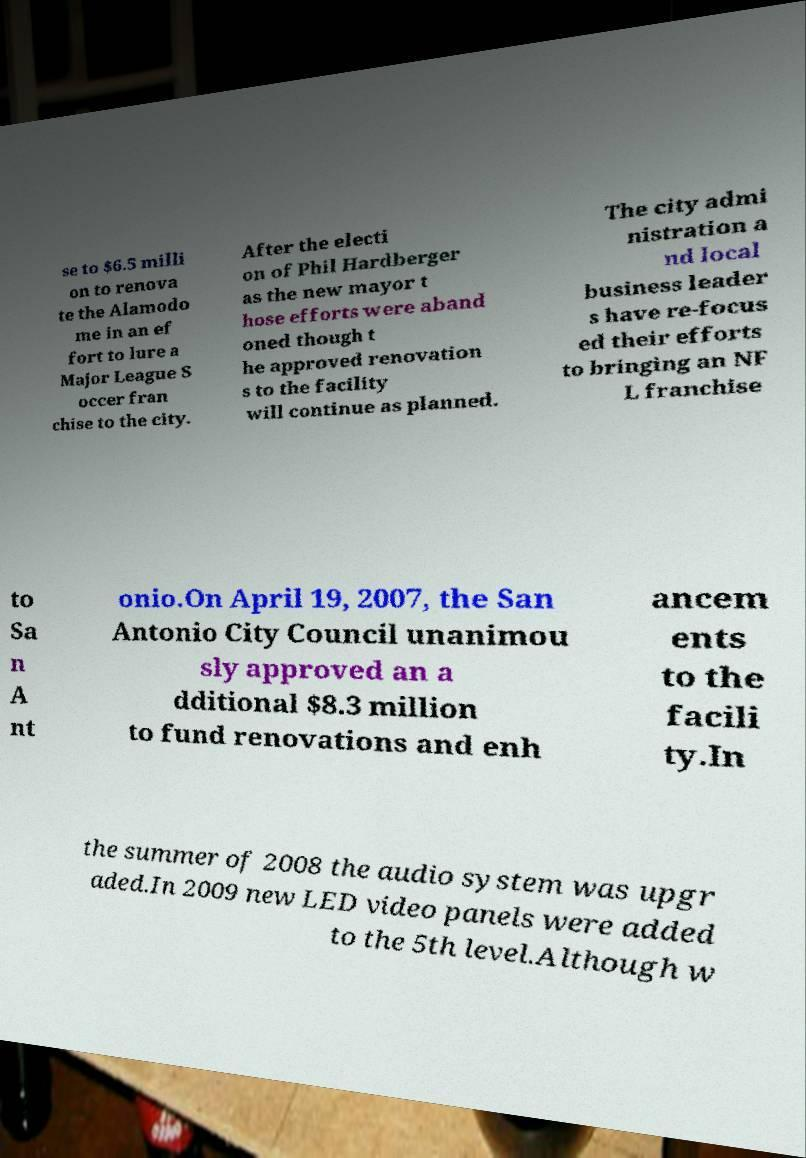Please read and relay the text visible in this image. What does it say? se to $6.5 milli on to renova te the Alamodo me in an ef fort to lure a Major League S occer fran chise to the city. After the electi on of Phil Hardberger as the new mayor t hose efforts were aband oned though t he approved renovation s to the facility will continue as planned. The city admi nistration a nd local business leader s have re-focus ed their efforts to bringing an NF L franchise to Sa n A nt onio.On April 19, 2007, the San Antonio City Council unanimou sly approved an a dditional $8.3 million to fund renovations and enh ancem ents to the facili ty.In the summer of 2008 the audio system was upgr aded.In 2009 new LED video panels were added to the 5th level.Although w 